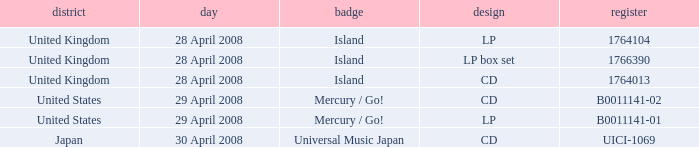Would you be able to parse every entry in this table? {'header': ['district', 'day', 'badge', 'design', 'register'], 'rows': [['United Kingdom', '28 April 2008', 'Island', 'LP', '1764104'], ['United Kingdom', '28 April 2008', 'Island', 'LP box set', '1766390'], ['United Kingdom', '28 April 2008', 'Island', 'CD', '1764013'], ['United States', '29 April 2008', 'Mercury / Go!', 'CD', 'B0011141-02'], ['United States', '29 April 2008', 'Mercury / Go!', 'LP', 'B0011141-01'], ['Japan', '30 April 2008', 'Universal Music Japan', 'CD', 'UICI-1069']]} What is the Label of the B0011141-01 Catalog? Mercury / Go!. 